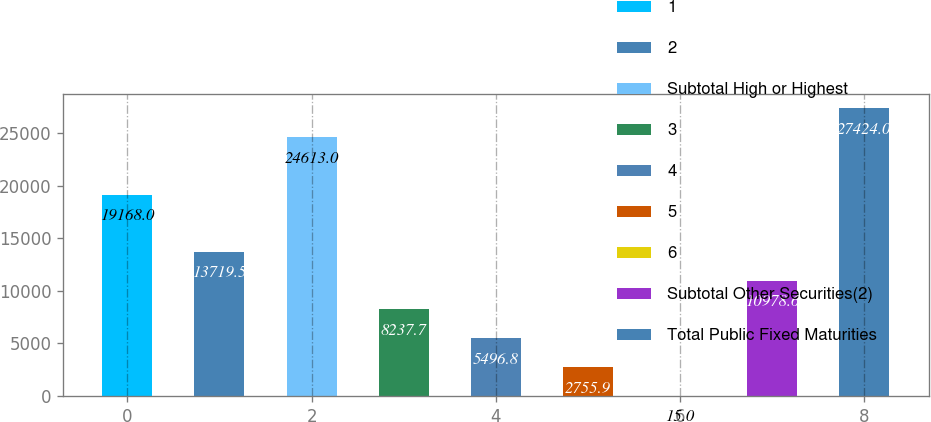Convert chart. <chart><loc_0><loc_0><loc_500><loc_500><bar_chart><fcel>1<fcel>2<fcel>Subtotal High or Highest<fcel>3<fcel>4<fcel>5<fcel>6<fcel>Subtotal Other Securities(2)<fcel>Total Public Fixed Maturities<nl><fcel>19168<fcel>13719.5<fcel>24613<fcel>8237.7<fcel>5496.8<fcel>2755.9<fcel>15<fcel>10978.6<fcel>27424<nl></chart> 